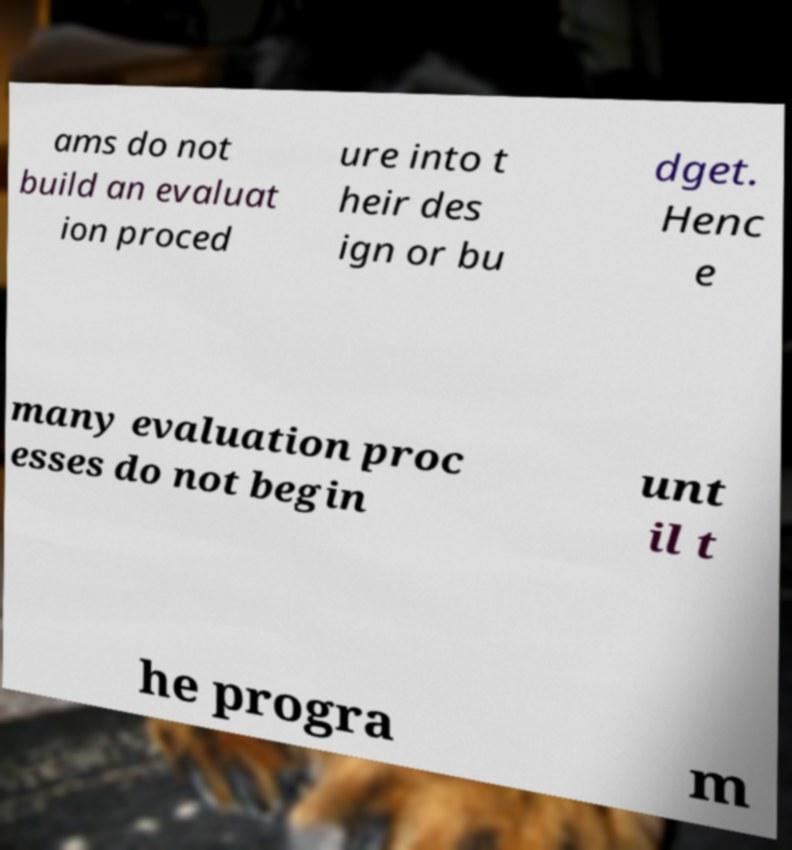Could you extract and type out the text from this image? ams do not build an evaluat ion proced ure into t heir des ign or bu dget. Henc e many evaluation proc esses do not begin unt il t he progra m 